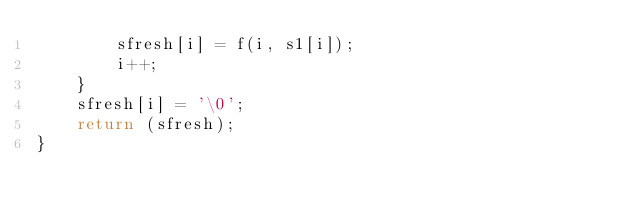Convert code to text. <code><loc_0><loc_0><loc_500><loc_500><_C_>		sfresh[i] = f(i, s1[i]);
		i++;
	}
	sfresh[i] = '\0';
	return (sfresh);
}
</code> 